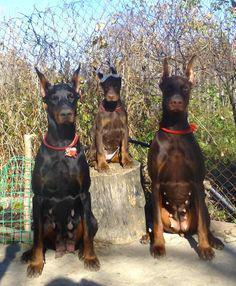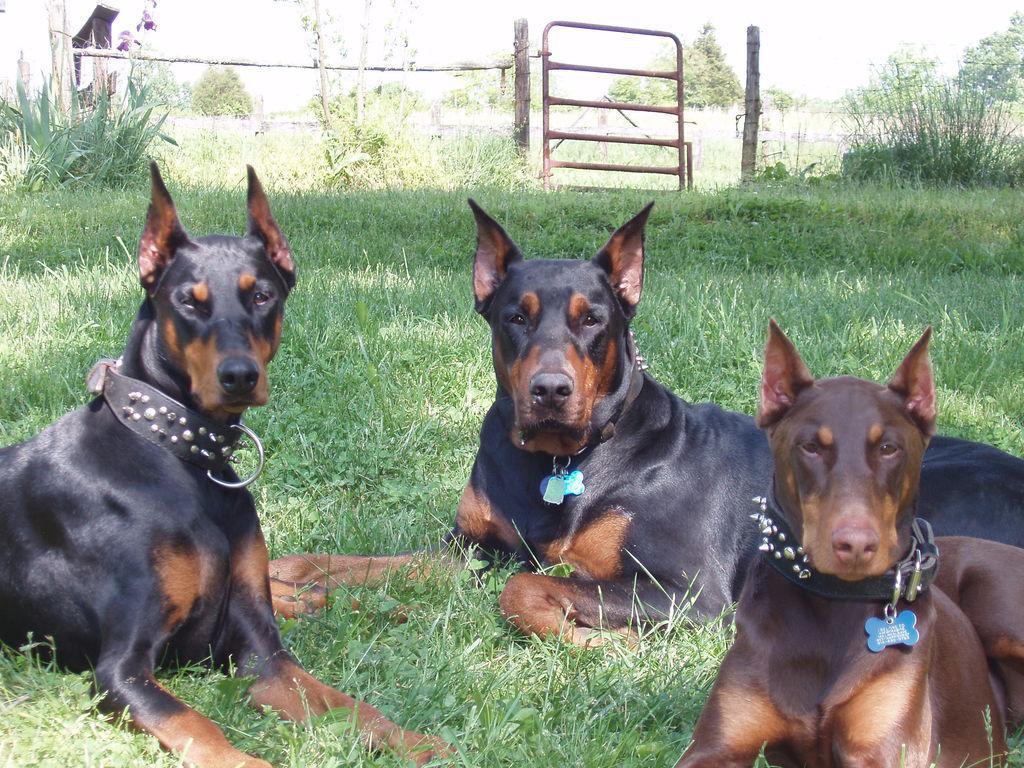The first image is the image on the left, the second image is the image on the right. Considering the images on both sides, is "There are three dogs exactly in each image." valid? Answer yes or no. Yes. The first image is the image on the left, the second image is the image on the right. Analyze the images presented: Is the assertion "Every picture has 3 dogs in it." valid? Answer yes or no. Yes. 